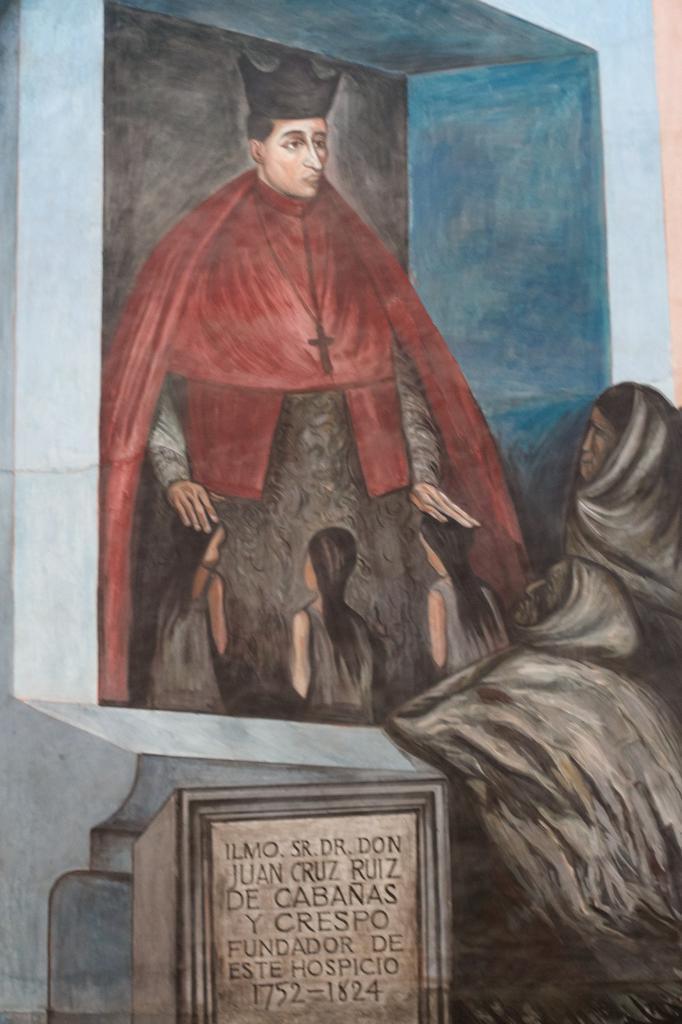Describe this image in one or two sentences. In this image, we can see a painting. Here we can see a person is standing. On the right side of the image, we can see two people. At the bottom of the image, we can see some text on the object. 